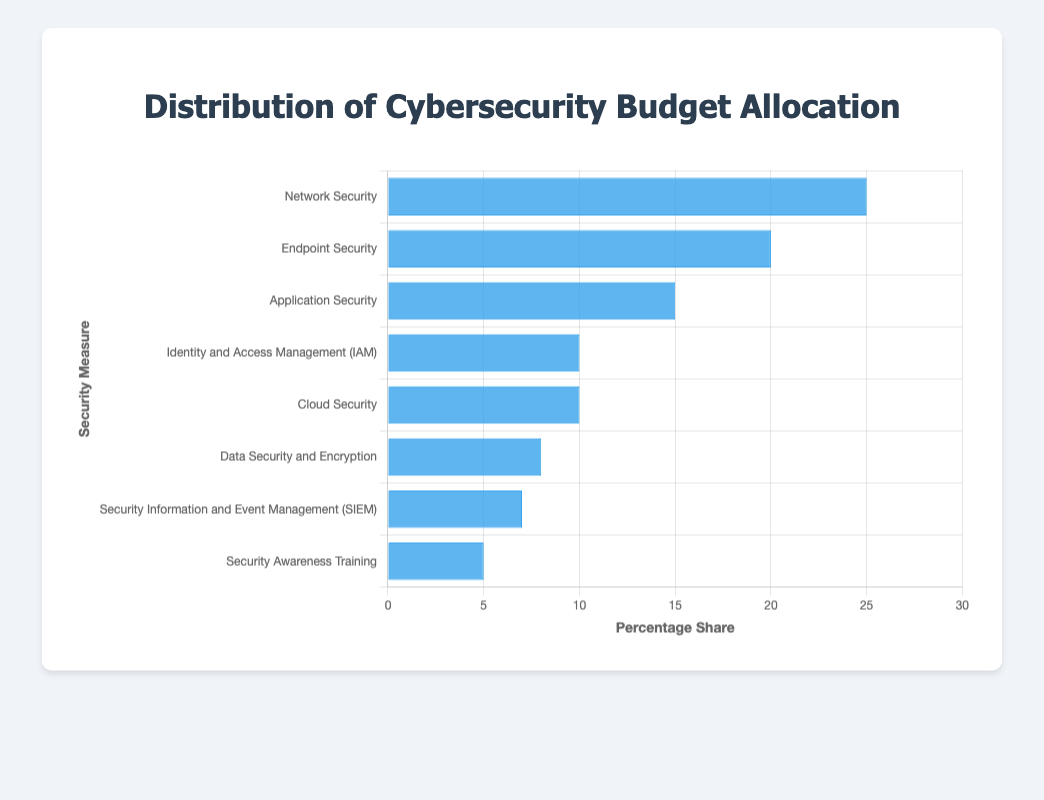What is the total percentage allocated to Network Security, Endpoint Security, and Application Security combined? To find the total percentage for Network Security, Endpoint Security, and Application Security, add their individual percentages: 25% (Network Security) + 20% (Endpoint Security) + 15% (Application Security) = 60%.
Answer: 60% Which security measure has the lowest budget allocation? By observing the bars, the shortest bar corresponds to Security Awareness Training, which has a percentage share of 5%, the lowest among the measures listed.
Answer: Security Awareness Training How much more budget allocation does Network Security receive compared to Cloud Security? Network Security receives 25% while Cloud Security receives 10%. The difference is 25% - 10% = 15%.
Answer: 15% What is the average budget allocation percentage for Identity and Access Management (IAM), Cloud Security, and Data Security and Encryption? Add the percentages for IAM (10%), Cloud Security (10%), and Data Security and Encryption (8%), and then divide by the number of measures: (10+10+8)/3 = 28/3 ≈ 9.33%.
Answer: 9.33% Place the security measures in descending order based on their budget allocation percentage. Sort the measures based on their percentages: 1. Network Security (25%), 2. Endpoint Security (20%), 3. Application Security (15%), 4. Identity and Access Management (IAM) (10%), 5. Cloud Security (10%), 6. Data Security and Encryption (8%), 7. Security Information and Event Management (SIEM) (7%), 8. Security Awareness Training (5%).
Answer: Network Security, Endpoint Security, Application Security, IAM, Cloud Security, Data Security and Encryption, SIEM, Security Awareness Training What percentage of the budget is allocated to measures other than Network Security and Endpoint Security? Subtract the combined percentage of Network Security and Endpoint Security from 100%: 100% - (25% + 20%) = 55%.
Answer: 55% Which two security measures have the same budget allocation percentage? By inspecting the bars, both Identity and Access Management (IAM) and Cloud Security have the same percentage allocation of 10%.
Answer: IAM and Cloud Security How does the budget allocation for Security Awareness Training compare to Security Information and Event Management (SIEM)? Security Awareness Training has a bar height corresponding to 5%, while SIEM has a bar height corresponding to 7%. Therefore, Security Awareness Training receives 2% less budget allocation than SIEM.
Answer: 2% less 